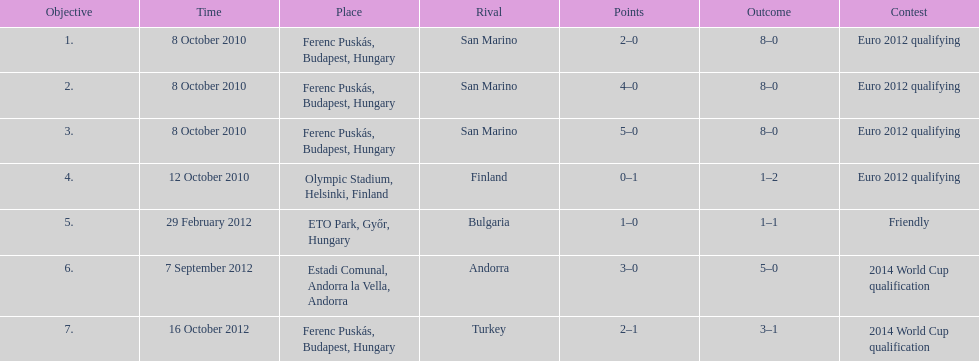When did ádám szalai make his first international goal? 8 October 2010. 